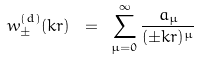Convert formula to latex. <formula><loc_0><loc_0><loc_500><loc_500>w _ { \pm } ^ { ( d ) } ( k r ) \ = \ \sum _ { \mu = 0 } ^ { \infty } \frac { a _ { \mu } } { ( \pm k r ) ^ { \mu } }</formula> 